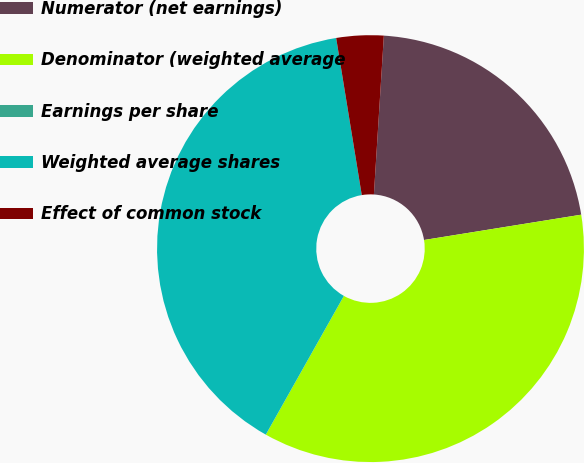<chart> <loc_0><loc_0><loc_500><loc_500><pie_chart><fcel>Numerator (net earnings)<fcel>Denominator (weighted average<fcel>Earnings per share<fcel>Weighted average shares<fcel>Effect of common stock<nl><fcel>21.46%<fcel>35.7%<fcel>0.0%<fcel>39.27%<fcel>3.57%<nl></chart> 